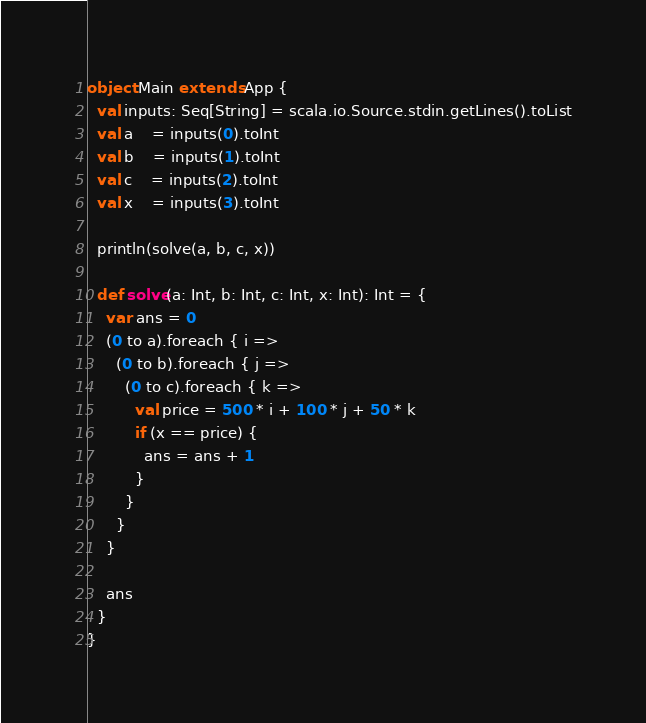<code> <loc_0><loc_0><loc_500><loc_500><_Scala_>object Main extends App {
  val inputs: Seq[String] = scala.io.Source.stdin.getLines().toList
  val a    = inputs(0).toInt
  val b    = inputs(1).toInt
  val c    = inputs(2).toInt
  val x    = inputs(3).toInt

  println(solve(a, b, c, x))

  def solve(a: Int, b: Int, c: Int, x: Int): Int = {
    var ans = 0
    (0 to a).foreach { i =>
      (0 to b).foreach { j =>
        (0 to c).foreach { k =>
          val price = 500 * i + 100 * j + 50 * k
          if (x == price) {
            ans = ans + 1
          }
        }
      }
    }

    ans
  }
}</code> 